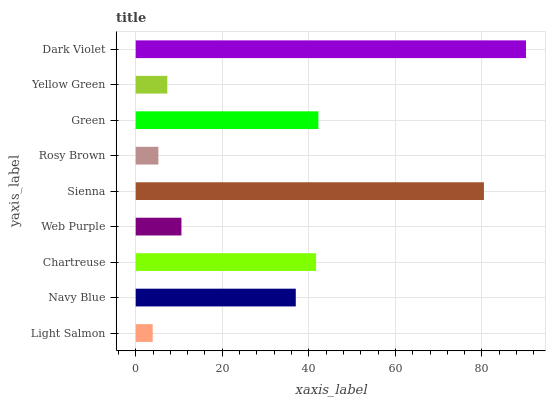Is Light Salmon the minimum?
Answer yes or no. Yes. Is Dark Violet the maximum?
Answer yes or no. Yes. Is Navy Blue the minimum?
Answer yes or no. No. Is Navy Blue the maximum?
Answer yes or no. No. Is Navy Blue greater than Light Salmon?
Answer yes or no. Yes. Is Light Salmon less than Navy Blue?
Answer yes or no. Yes. Is Light Salmon greater than Navy Blue?
Answer yes or no. No. Is Navy Blue less than Light Salmon?
Answer yes or no. No. Is Navy Blue the high median?
Answer yes or no. Yes. Is Navy Blue the low median?
Answer yes or no. Yes. Is Web Purple the high median?
Answer yes or no. No. Is Chartreuse the low median?
Answer yes or no. No. 